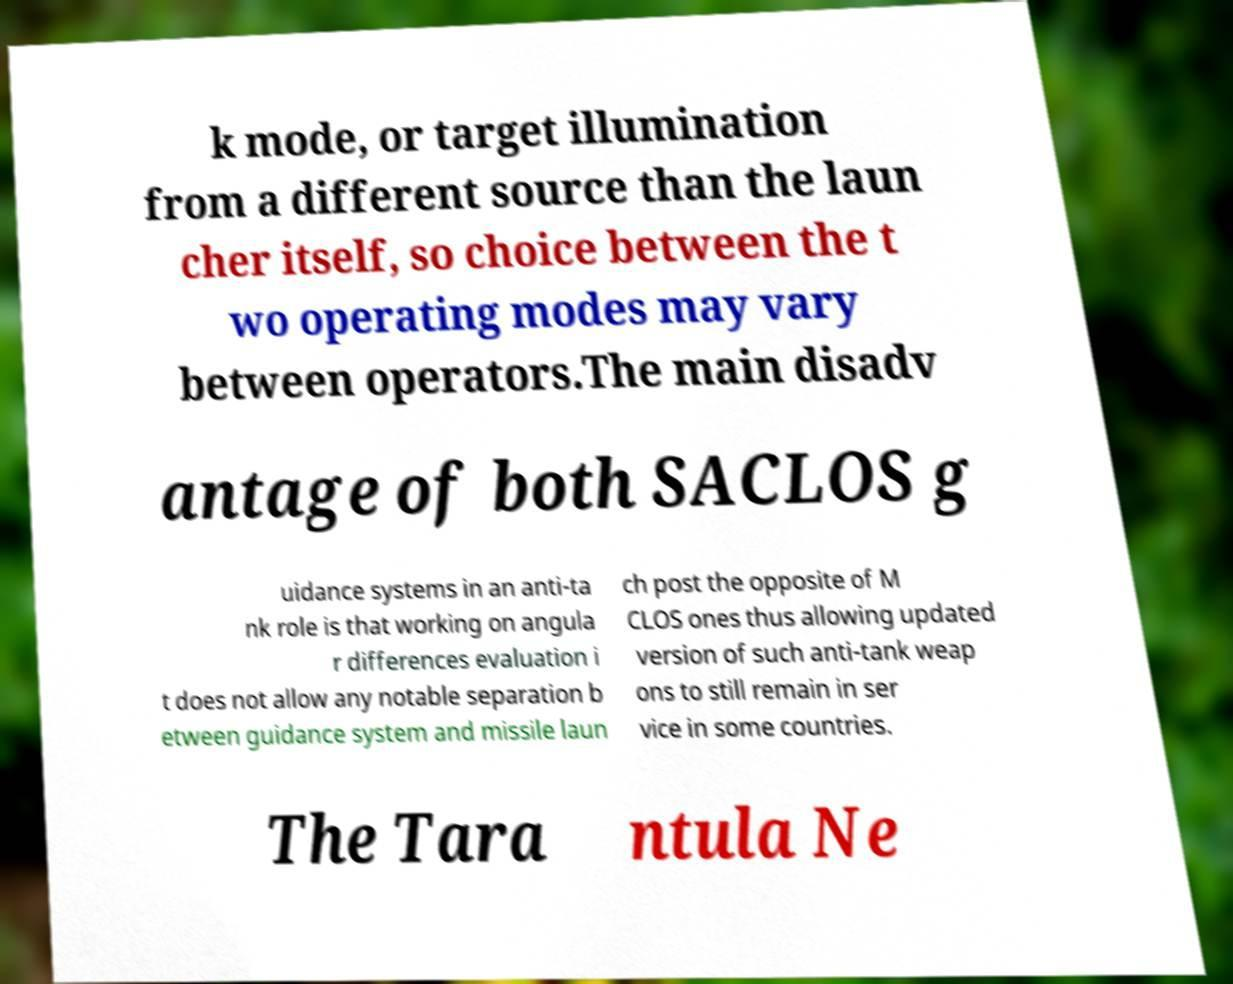Can you read and provide the text displayed in the image?This photo seems to have some interesting text. Can you extract and type it out for me? k mode, or target illumination from a different source than the laun cher itself, so choice between the t wo operating modes may vary between operators.The main disadv antage of both SACLOS g uidance systems in an anti-ta nk role is that working on angula r differences evaluation i t does not allow any notable separation b etween guidance system and missile laun ch post the opposite of M CLOS ones thus allowing updated version of such anti-tank weap ons to still remain in ser vice in some countries. The Tara ntula Ne 